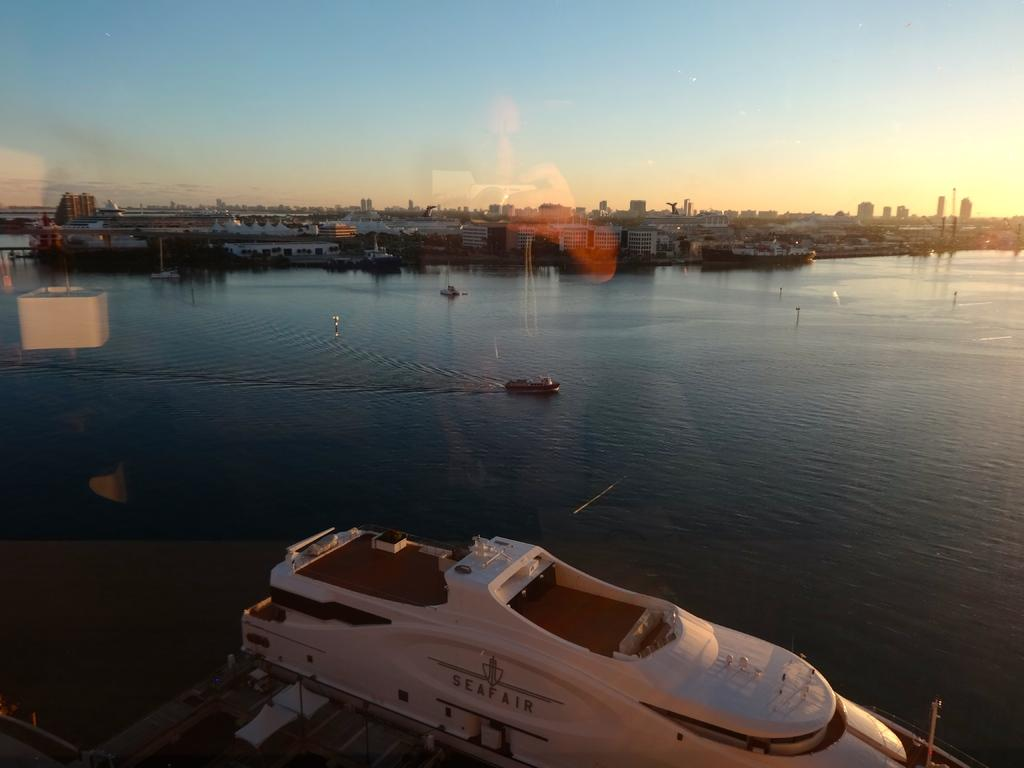What type of vehicles can be seen in the image? There are boats in the image. Can you describe the color of one of the boats? There is a white boat in the image. What natural element is visible in the image? There is water visible in the image. What type of structures can be seen in the image? There are buildings in the image. What type of vegetation is present in the image? There are trees in the image. How would you describe the color of the sky in the image? The sky is a combination of white and blue colors in the image. What type of machine can be seen drawing on the white boat in the image? There is no machine present in the image, nor is there any drawing on the white boat. 